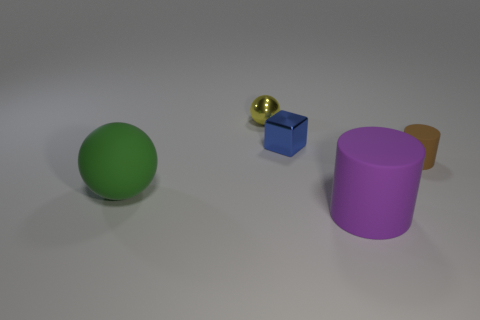Is there anything else that is the same shape as the blue object?
Your answer should be compact. No. What number of brown matte balls are there?
Your answer should be compact. 0. There is a cylinder that is in front of the small matte thing; what is its size?
Ensure brevity in your answer.  Large. What number of other matte balls are the same size as the green sphere?
Your answer should be compact. 0. There is a small object that is in front of the tiny yellow sphere and on the left side of the tiny brown thing; what material is it made of?
Your response must be concise. Metal. There is a blue block that is the same size as the metallic sphere; what material is it?
Make the answer very short. Metal. How big is the rubber thing that is in front of the big object to the left of the tiny shiny thing to the left of the small blue metal thing?
Your answer should be compact. Large. What is the size of the other cylinder that is made of the same material as the small cylinder?
Ensure brevity in your answer.  Large. Does the yellow metal object have the same size as the cylinder behind the big matte ball?
Provide a succinct answer. Yes. The matte thing that is on the right side of the purple matte cylinder has what shape?
Your answer should be very brief. Cylinder. 